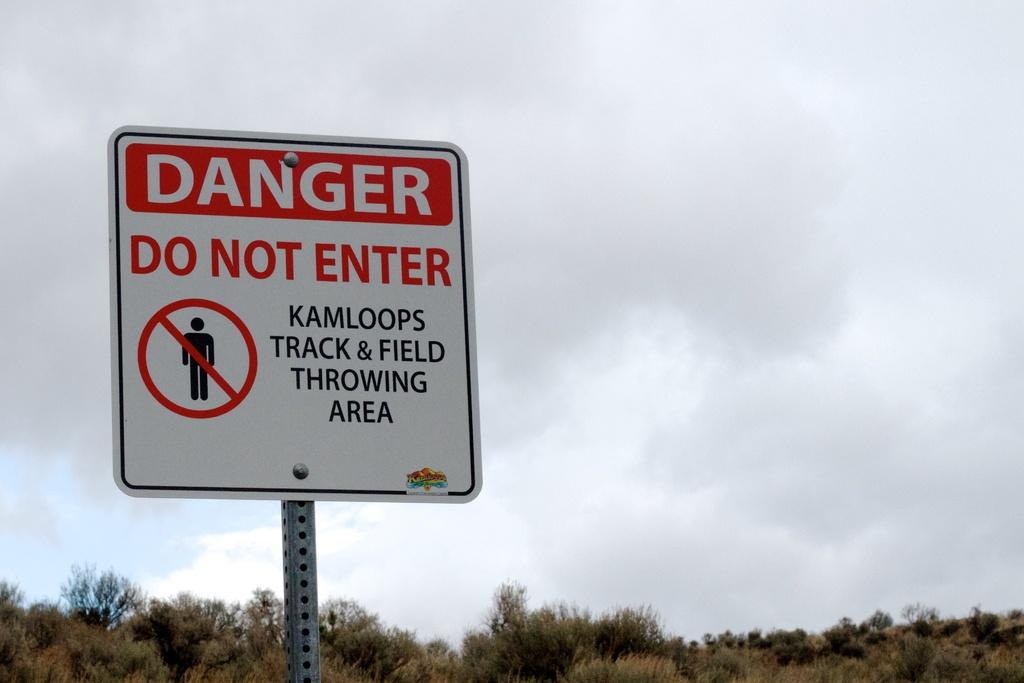<image>
Relay a brief, clear account of the picture shown. A warning sign to not enter the track & field area. 